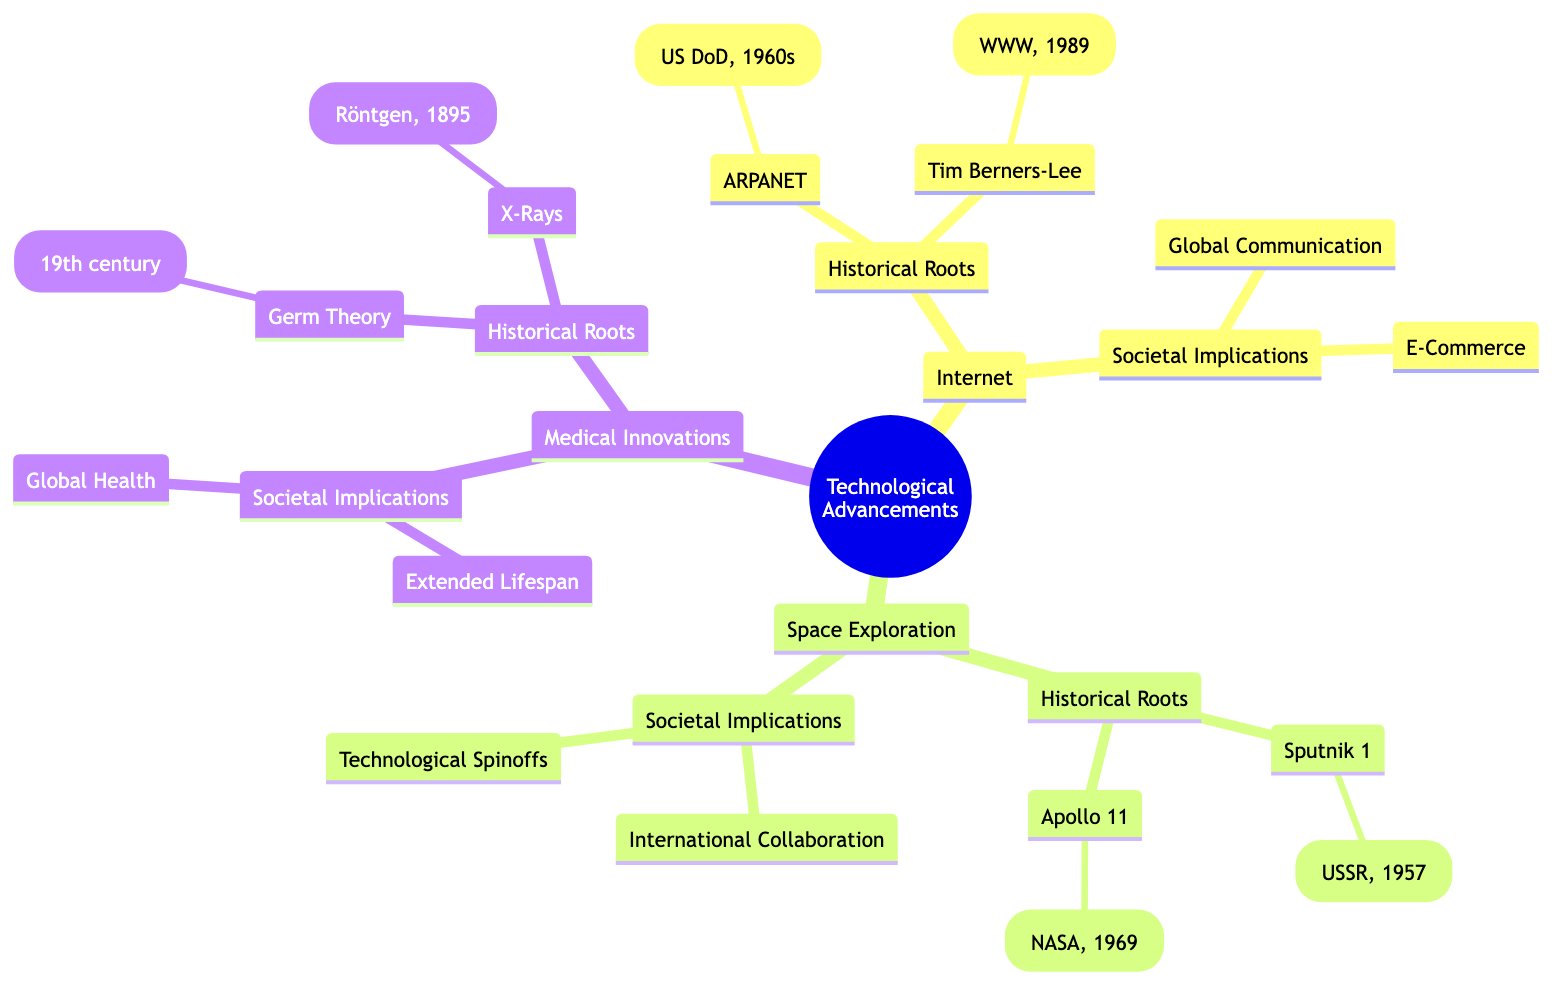What is the first artificial satellite mentioned in the diagram? The node under "Space Exploration" labeled "Sputnik 1" states that it was launched by the Soviet Union in 1957 and is identified as the first artificial satellite.
Answer: Sputnik 1 Who invented the World Wide Web? The node under "Internet" labeled "Tim Berners-Lee" indicates that he invented the World Wide Web in 1989.
Answer: Tim Berners-Lee How many technological areas are covered in the mind map? The diagram outlines three main branches under "Technological Advancements": Internet, Space Exploration, and Medical Innovations. Thus, there are three technological areas covered.
Answer: 3 What significant advancement did Apollo 11 achieve? The diagram notes that Apollo 11 was NASA's mission in 1969 that landed the first humans on the Moon, thus indicating a significant achievement in space exploration.
Answer: First humans on the Moon What innovative impact did the Germ Theory have on medicine? Under the "Medical Innovations" branch, Germ Theory is stated as having been established in the 19th century and thus revolutionized our understanding of diseases, implying its major impact on medical science.
Answer: Revolutionized understanding of diseases What are two societal implications of the Internet mentioned in the diagram? The "Societal Implications" node under "Internet" mentions both "Global Communication" and "E-Commerce" as significant implications of internet technology for society.
Answer: Global Communication, E-Commerce How did space exploration promote international collaboration? The mind map highlights "International Collaboration" as one societal implication of space exploration, particularly through entities like the ISS (International Space Station). This signifies collaboration among nations in space endeavors.
Answer: Promoted cooperation Which discovery revolutionized diagnostic medicine according to the diagram? The node under "Medical Innovations" for "X-Rays" mentions that they were discovered by Wilhelm Röntgen in 1895, explicitly stating that this revolutionized diagnostic medicine.
Answer: X-Rays What societal implication is linked to advancements in medical technology? The diagram connects the enhancement of "Global Health" as a societal implication due to medical innovations, indicating how advancements allow for better management of health challenges worldwide.
Answer: Global Health 